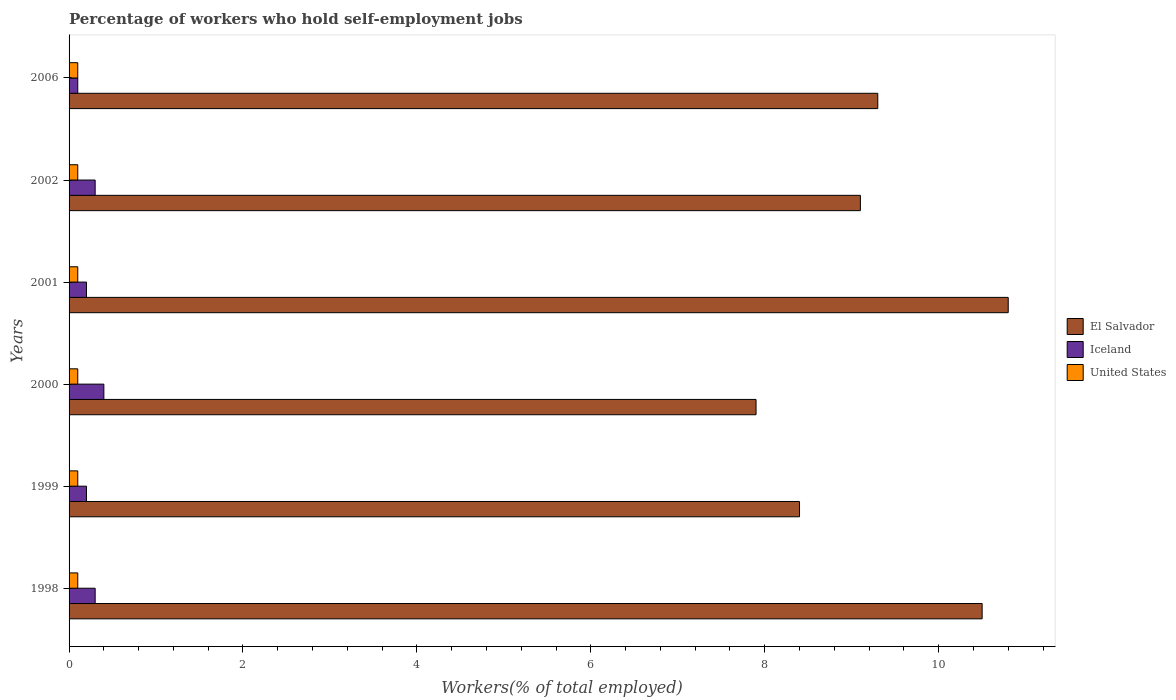How many different coloured bars are there?
Give a very brief answer. 3. Are the number of bars per tick equal to the number of legend labels?
Keep it short and to the point. Yes. Are the number of bars on each tick of the Y-axis equal?
Keep it short and to the point. Yes. How many bars are there on the 6th tick from the top?
Your response must be concise. 3. What is the label of the 4th group of bars from the top?
Ensure brevity in your answer.  2000. What is the percentage of self-employed workers in El Salvador in 2000?
Provide a short and direct response. 7.9. Across all years, what is the maximum percentage of self-employed workers in United States?
Keep it short and to the point. 0.1. Across all years, what is the minimum percentage of self-employed workers in El Salvador?
Your answer should be compact. 7.9. In which year was the percentage of self-employed workers in El Salvador minimum?
Provide a succinct answer. 2000. What is the total percentage of self-employed workers in United States in the graph?
Make the answer very short. 0.6. What is the difference between the percentage of self-employed workers in Iceland in 2000 and the percentage of self-employed workers in United States in 1999?
Your answer should be compact. 0.3. What is the average percentage of self-employed workers in El Salvador per year?
Make the answer very short. 9.33. In the year 1998, what is the difference between the percentage of self-employed workers in Iceland and percentage of self-employed workers in El Salvador?
Provide a short and direct response. -10.2. In how many years, is the percentage of self-employed workers in Iceland greater than 9.2 %?
Provide a succinct answer. 0. What is the ratio of the percentage of self-employed workers in El Salvador in 2002 to that in 2006?
Ensure brevity in your answer.  0.98. Is the percentage of self-employed workers in United States in 2002 less than that in 2006?
Your answer should be compact. No. What is the difference between the highest and the second highest percentage of self-employed workers in El Salvador?
Provide a succinct answer. 0.3. What is the difference between the highest and the lowest percentage of self-employed workers in Iceland?
Provide a short and direct response. 0.3. In how many years, is the percentage of self-employed workers in Iceland greater than the average percentage of self-employed workers in Iceland taken over all years?
Keep it short and to the point. 3. Is the sum of the percentage of self-employed workers in Iceland in 1999 and 2000 greater than the maximum percentage of self-employed workers in United States across all years?
Provide a short and direct response. Yes. What does the 3rd bar from the top in 2006 represents?
Make the answer very short. El Salvador. What does the 3rd bar from the bottom in 2001 represents?
Your answer should be compact. United States. Is it the case that in every year, the sum of the percentage of self-employed workers in Iceland and percentage of self-employed workers in El Salvador is greater than the percentage of self-employed workers in United States?
Offer a very short reply. Yes. How many bars are there?
Keep it short and to the point. 18. Are all the bars in the graph horizontal?
Offer a very short reply. Yes. What is the difference between two consecutive major ticks on the X-axis?
Offer a very short reply. 2. Are the values on the major ticks of X-axis written in scientific E-notation?
Keep it short and to the point. No. Does the graph contain grids?
Provide a short and direct response. No. What is the title of the graph?
Your response must be concise. Percentage of workers who hold self-employment jobs. Does "Virgin Islands" appear as one of the legend labels in the graph?
Your answer should be very brief. No. What is the label or title of the X-axis?
Offer a terse response. Workers(% of total employed). What is the label or title of the Y-axis?
Offer a terse response. Years. What is the Workers(% of total employed) in El Salvador in 1998?
Ensure brevity in your answer.  10.5. What is the Workers(% of total employed) of Iceland in 1998?
Provide a succinct answer. 0.3. What is the Workers(% of total employed) of United States in 1998?
Your answer should be compact. 0.1. What is the Workers(% of total employed) of El Salvador in 1999?
Keep it short and to the point. 8.4. What is the Workers(% of total employed) in Iceland in 1999?
Your answer should be very brief. 0.2. What is the Workers(% of total employed) in United States in 1999?
Give a very brief answer. 0.1. What is the Workers(% of total employed) of El Salvador in 2000?
Provide a succinct answer. 7.9. What is the Workers(% of total employed) in Iceland in 2000?
Your answer should be compact. 0.4. What is the Workers(% of total employed) in United States in 2000?
Offer a very short reply. 0.1. What is the Workers(% of total employed) of El Salvador in 2001?
Your response must be concise. 10.8. What is the Workers(% of total employed) in Iceland in 2001?
Offer a very short reply. 0.2. What is the Workers(% of total employed) in United States in 2001?
Provide a succinct answer. 0.1. What is the Workers(% of total employed) of El Salvador in 2002?
Give a very brief answer. 9.1. What is the Workers(% of total employed) in Iceland in 2002?
Provide a succinct answer. 0.3. What is the Workers(% of total employed) in United States in 2002?
Offer a terse response. 0.1. What is the Workers(% of total employed) in El Salvador in 2006?
Keep it short and to the point. 9.3. What is the Workers(% of total employed) of Iceland in 2006?
Provide a short and direct response. 0.1. What is the Workers(% of total employed) in United States in 2006?
Offer a terse response. 0.1. Across all years, what is the maximum Workers(% of total employed) of El Salvador?
Give a very brief answer. 10.8. Across all years, what is the maximum Workers(% of total employed) in Iceland?
Offer a very short reply. 0.4. Across all years, what is the maximum Workers(% of total employed) of United States?
Keep it short and to the point. 0.1. Across all years, what is the minimum Workers(% of total employed) in El Salvador?
Provide a succinct answer. 7.9. Across all years, what is the minimum Workers(% of total employed) in Iceland?
Your response must be concise. 0.1. Across all years, what is the minimum Workers(% of total employed) in United States?
Ensure brevity in your answer.  0.1. What is the total Workers(% of total employed) of Iceland in the graph?
Make the answer very short. 1.5. What is the total Workers(% of total employed) in United States in the graph?
Your answer should be compact. 0.6. What is the difference between the Workers(% of total employed) of El Salvador in 1998 and that in 2001?
Ensure brevity in your answer.  -0.3. What is the difference between the Workers(% of total employed) in United States in 1998 and that in 2001?
Your answer should be very brief. 0. What is the difference between the Workers(% of total employed) of Iceland in 1998 and that in 2002?
Your answer should be compact. 0. What is the difference between the Workers(% of total employed) of United States in 1998 and that in 2002?
Provide a succinct answer. 0. What is the difference between the Workers(% of total employed) in El Salvador in 1998 and that in 2006?
Your answer should be very brief. 1.2. What is the difference between the Workers(% of total employed) in United States in 1998 and that in 2006?
Offer a terse response. 0. What is the difference between the Workers(% of total employed) in El Salvador in 1999 and that in 2000?
Your answer should be compact. 0.5. What is the difference between the Workers(% of total employed) in Iceland in 1999 and that in 2000?
Your response must be concise. -0.2. What is the difference between the Workers(% of total employed) in El Salvador in 1999 and that in 2001?
Provide a short and direct response. -2.4. What is the difference between the Workers(% of total employed) in El Salvador in 1999 and that in 2002?
Make the answer very short. -0.7. What is the difference between the Workers(% of total employed) in United States in 1999 and that in 2002?
Provide a short and direct response. 0. What is the difference between the Workers(% of total employed) of Iceland in 1999 and that in 2006?
Offer a terse response. 0.1. What is the difference between the Workers(% of total employed) in El Salvador in 2000 and that in 2001?
Your response must be concise. -2.9. What is the difference between the Workers(% of total employed) in United States in 2000 and that in 2001?
Offer a terse response. 0. What is the difference between the Workers(% of total employed) of United States in 2000 and that in 2002?
Offer a very short reply. 0. What is the difference between the Workers(% of total employed) of El Salvador in 2001 and that in 2002?
Your response must be concise. 1.7. What is the difference between the Workers(% of total employed) in Iceland in 2001 and that in 2002?
Offer a terse response. -0.1. What is the difference between the Workers(% of total employed) of United States in 2001 and that in 2002?
Your answer should be compact. 0. What is the difference between the Workers(% of total employed) of United States in 2001 and that in 2006?
Your response must be concise. 0. What is the difference between the Workers(% of total employed) of El Salvador in 1998 and the Workers(% of total employed) of Iceland in 1999?
Keep it short and to the point. 10.3. What is the difference between the Workers(% of total employed) in El Salvador in 1998 and the Workers(% of total employed) in Iceland in 2000?
Offer a very short reply. 10.1. What is the difference between the Workers(% of total employed) of El Salvador in 1998 and the Workers(% of total employed) of United States in 2001?
Your answer should be compact. 10.4. What is the difference between the Workers(% of total employed) in Iceland in 1998 and the Workers(% of total employed) in United States in 2001?
Your answer should be compact. 0.2. What is the difference between the Workers(% of total employed) in El Salvador in 1998 and the Workers(% of total employed) in Iceland in 2006?
Keep it short and to the point. 10.4. What is the difference between the Workers(% of total employed) of Iceland in 1998 and the Workers(% of total employed) of United States in 2006?
Provide a short and direct response. 0.2. What is the difference between the Workers(% of total employed) of Iceland in 1999 and the Workers(% of total employed) of United States in 2000?
Provide a short and direct response. 0.1. What is the difference between the Workers(% of total employed) of El Salvador in 1999 and the Workers(% of total employed) of Iceland in 2001?
Provide a short and direct response. 8.2. What is the difference between the Workers(% of total employed) in Iceland in 1999 and the Workers(% of total employed) in United States in 2001?
Keep it short and to the point. 0.1. What is the difference between the Workers(% of total employed) in El Salvador in 1999 and the Workers(% of total employed) in United States in 2002?
Provide a short and direct response. 8.3. What is the difference between the Workers(% of total employed) of El Salvador in 1999 and the Workers(% of total employed) of United States in 2006?
Offer a very short reply. 8.3. What is the difference between the Workers(% of total employed) in Iceland in 1999 and the Workers(% of total employed) in United States in 2006?
Keep it short and to the point. 0.1. What is the difference between the Workers(% of total employed) in El Salvador in 2000 and the Workers(% of total employed) in Iceland in 2001?
Ensure brevity in your answer.  7.7. What is the difference between the Workers(% of total employed) in El Salvador in 2000 and the Workers(% of total employed) in United States in 2001?
Ensure brevity in your answer.  7.8. What is the difference between the Workers(% of total employed) in Iceland in 2000 and the Workers(% of total employed) in United States in 2001?
Your answer should be compact. 0.3. What is the difference between the Workers(% of total employed) of El Salvador in 2000 and the Workers(% of total employed) of Iceland in 2002?
Make the answer very short. 7.6. What is the difference between the Workers(% of total employed) of El Salvador in 2000 and the Workers(% of total employed) of United States in 2002?
Offer a terse response. 7.8. What is the difference between the Workers(% of total employed) in El Salvador in 2000 and the Workers(% of total employed) in Iceland in 2006?
Give a very brief answer. 7.8. What is the difference between the Workers(% of total employed) in Iceland in 2000 and the Workers(% of total employed) in United States in 2006?
Your answer should be very brief. 0.3. What is the difference between the Workers(% of total employed) of El Salvador in 2001 and the Workers(% of total employed) of Iceland in 2002?
Your answer should be compact. 10.5. What is the difference between the Workers(% of total employed) in Iceland in 2001 and the Workers(% of total employed) in United States in 2002?
Your answer should be compact. 0.1. What is the difference between the Workers(% of total employed) of El Salvador in 2002 and the Workers(% of total employed) of Iceland in 2006?
Ensure brevity in your answer.  9. What is the difference between the Workers(% of total employed) in El Salvador in 2002 and the Workers(% of total employed) in United States in 2006?
Ensure brevity in your answer.  9. What is the difference between the Workers(% of total employed) of Iceland in 2002 and the Workers(% of total employed) of United States in 2006?
Ensure brevity in your answer.  0.2. What is the average Workers(% of total employed) in El Salvador per year?
Your answer should be very brief. 9.33. In the year 1998, what is the difference between the Workers(% of total employed) in El Salvador and Workers(% of total employed) in United States?
Ensure brevity in your answer.  10.4. In the year 1999, what is the difference between the Workers(% of total employed) in Iceland and Workers(% of total employed) in United States?
Offer a terse response. 0.1. In the year 2000, what is the difference between the Workers(% of total employed) of El Salvador and Workers(% of total employed) of United States?
Your response must be concise. 7.8. In the year 2000, what is the difference between the Workers(% of total employed) in Iceland and Workers(% of total employed) in United States?
Your answer should be compact. 0.3. In the year 2002, what is the difference between the Workers(% of total employed) in El Salvador and Workers(% of total employed) in Iceland?
Provide a succinct answer. 8.8. In the year 2002, what is the difference between the Workers(% of total employed) of El Salvador and Workers(% of total employed) of United States?
Provide a succinct answer. 9. In the year 2006, what is the difference between the Workers(% of total employed) of Iceland and Workers(% of total employed) of United States?
Make the answer very short. 0. What is the ratio of the Workers(% of total employed) of United States in 1998 to that in 1999?
Your response must be concise. 1. What is the ratio of the Workers(% of total employed) in El Salvador in 1998 to that in 2000?
Your answer should be compact. 1.33. What is the ratio of the Workers(% of total employed) in Iceland in 1998 to that in 2000?
Give a very brief answer. 0.75. What is the ratio of the Workers(% of total employed) of El Salvador in 1998 to that in 2001?
Give a very brief answer. 0.97. What is the ratio of the Workers(% of total employed) of United States in 1998 to that in 2001?
Keep it short and to the point. 1. What is the ratio of the Workers(% of total employed) in El Salvador in 1998 to that in 2002?
Your answer should be very brief. 1.15. What is the ratio of the Workers(% of total employed) of Iceland in 1998 to that in 2002?
Provide a short and direct response. 1. What is the ratio of the Workers(% of total employed) in El Salvador in 1998 to that in 2006?
Provide a succinct answer. 1.13. What is the ratio of the Workers(% of total employed) of Iceland in 1998 to that in 2006?
Keep it short and to the point. 3. What is the ratio of the Workers(% of total employed) in United States in 1998 to that in 2006?
Provide a succinct answer. 1. What is the ratio of the Workers(% of total employed) of El Salvador in 1999 to that in 2000?
Make the answer very short. 1.06. What is the ratio of the Workers(% of total employed) in Iceland in 1999 to that in 2000?
Make the answer very short. 0.5. What is the ratio of the Workers(% of total employed) of United States in 1999 to that in 2000?
Offer a terse response. 1. What is the ratio of the Workers(% of total employed) of Iceland in 1999 to that in 2001?
Offer a terse response. 1. What is the ratio of the Workers(% of total employed) in Iceland in 1999 to that in 2002?
Give a very brief answer. 0.67. What is the ratio of the Workers(% of total employed) of El Salvador in 1999 to that in 2006?
Offer a terse response. 0.9. What is the ratio of the Workers(% of total employed) of United States in 1999 to that in 2006?
Keep it short and to the point. 1. What is the ratio of the Workers(% of total employed) of El Salvador in 2000 to that in 2001?
Provide a short and direct response. 0.73. What is the ratio of the Workers(% of total employed) of United States in 2000 to that in 2001?
Your answer should be compact. 1. What is the ratio of the Workers(% of total employed) of El Salvador in 2000 to that in 2002?
Offer a very short reply. 0.87. What is the ratio of the Workers(% of total employed) of Iceland in 2000 to that in 2002?
Your response must be concise. 1.33. What is the ratio of the Workers(% of total employed) in El Salvador in 2000 to that in 2006?
Your response must be concise. 0.85. What is the ratio of the Workers(% of total employed) in Iceland in 2000 to that in 2006?
Offer a very short reply. 4. What is the ratio of the Workers(% of total employed) of United States in 2000 to that in 2006?
Your answer should be very brief. 1. What is the ratio of the Workers(% of total employed) in El Salvador in 2001 to that in 2002?
Your answer should be compact. 1.19. What is the ratio of the Workers(% of total employed) of Iceland in 2001 to that in 2002?
Your answer should be very brief. 0.67. What is the ratio of the Workers(% of total employed) in United States in 2001 to that in 2002?
Ensure brevity in your answer.  1. What is the ratio of the Workers(% of total employed) in El Salvador in 2001 to that in 2006?
Provide a succinct answer. 1.16. What is the ratio of the Workers(% of total employed) in Iceland in 2001 to that in 2006?
Your response must be concise. 2. What is the ratio of the Workers(% of total employed) of United States in 2001 to that in 2006?
Your answer should be compact. 1. What is the ratio of the Workers(% of total employed) of El Salvador in 2002 to that in 2006?
Make the answer very short. 0.98. What is the difference between the highest and the second highest Workers(% of total employed) in United States?
Give a very brief answer. 0. 